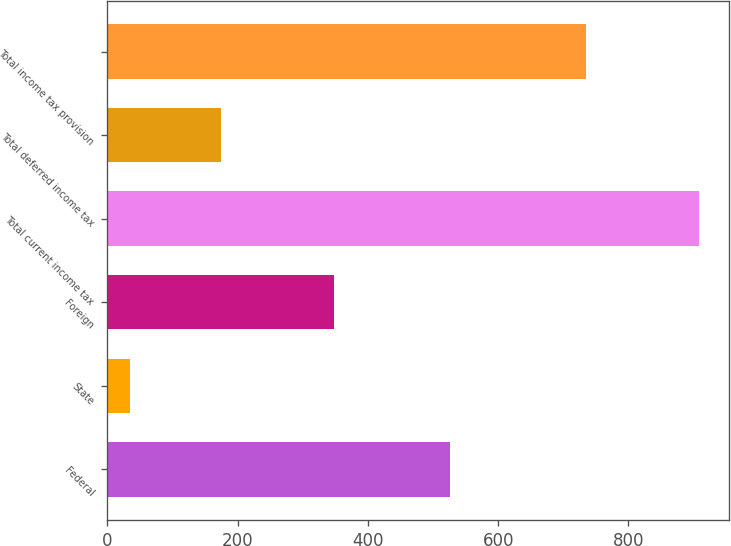Convert chart. <chart><loc_0><loc_0><loc_500><loc_500><bar_chart><fcel>Federal<fcel>State<fcel>Foreign<fcel>Total current income tax<fcel>Total deferred income tax<fcel>Total income tax provision<nl><fcel>526<fcel>35<fcel>348<fcel>909<fcel>174<fcel>735<nl></chart> 